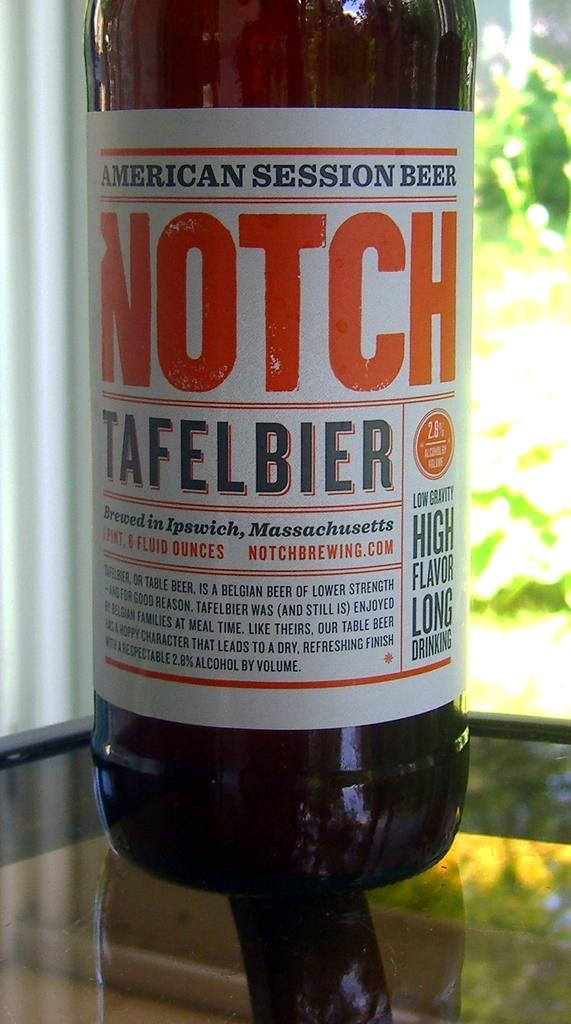What type of furniture is present in the image? There is a table in the image. What object can be seen on the table? There is a black color bottle on the table. What can be seen in the background of the image? There are plants in the background of the image. What is the color of the plants? The plants are green in color. Can you see the force of gravity affecting the bottle on the table in the image? The force of gravity is not visible in the image, but it is likely affecting the bottle on the table. Are the plants in the image smiling? Plants do not have the ability to smile, so they cannot be seen smiling in the image. 